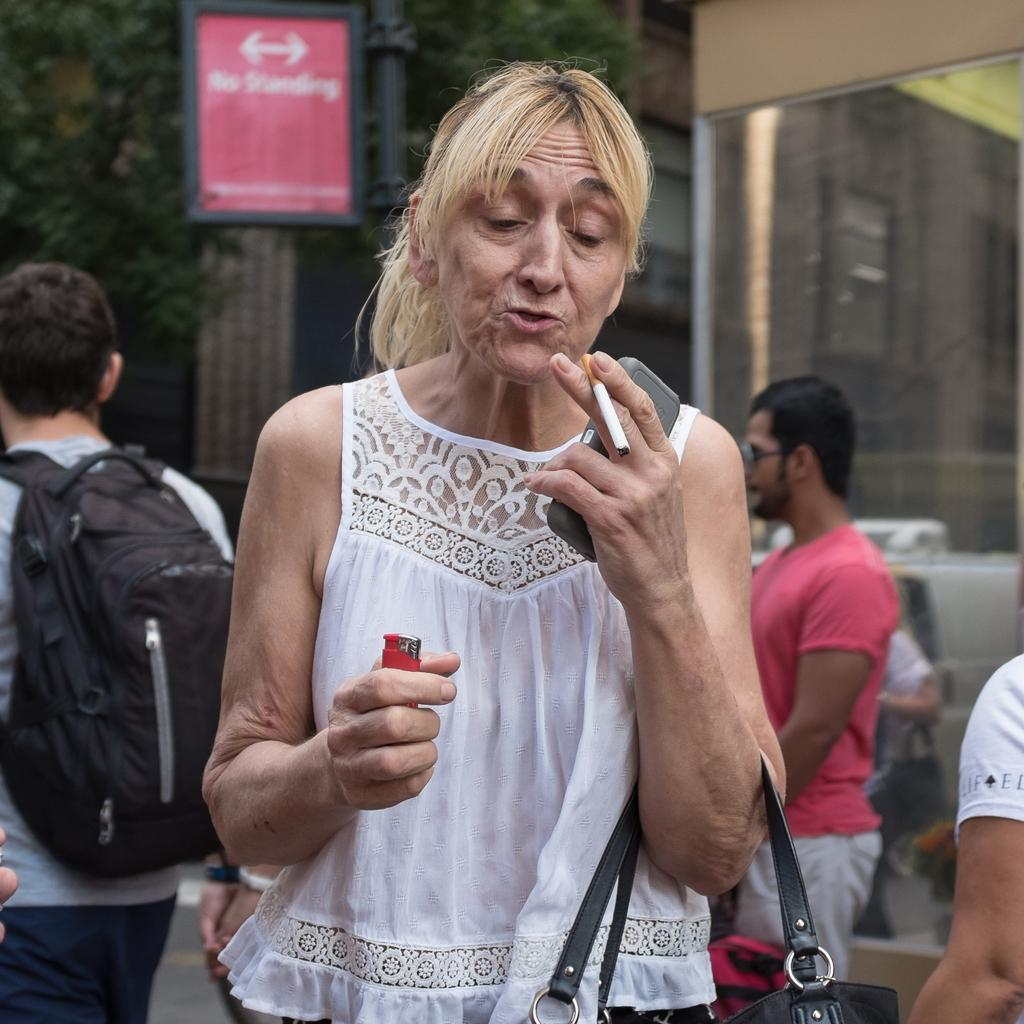What is the person in the foreground holding in the image? The person is holding a cigarette and a lighter in the image. Can you describe the people in the background of the image? There are people visible in the background of the image, and one of them is wearing a bag. What is present in the background of the image? There is a board in the background of the image. What type of stitch is being used to hold the feather in place in the image? There is no feather or stitching present in the image. 